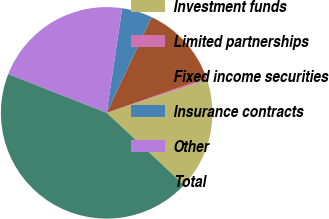<chart> <loc_0><loc_0><loc_500><loc_500><pie_chart><fcel>Investment funds<fcel>Limited partnerships<fcel>Fixed income securities<fcel>Insurance contracts<fcel>Other<fcel>Total<nl><fcel>17.02%<fcel>0.28%<fcel>12.65%<fcel>4.65%<fcel>21.39%<fcel>44.0%<nl></chart> 